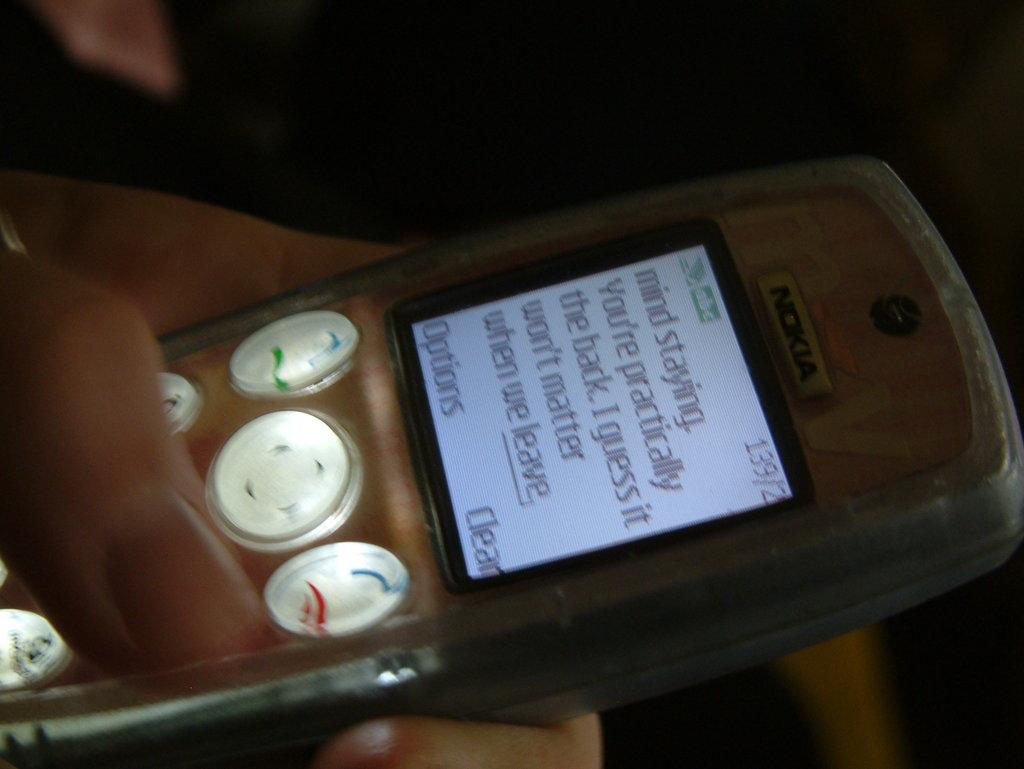<image>
Summarize the visual content of the image. a Nokia phone open to a display reading "mind staying." 